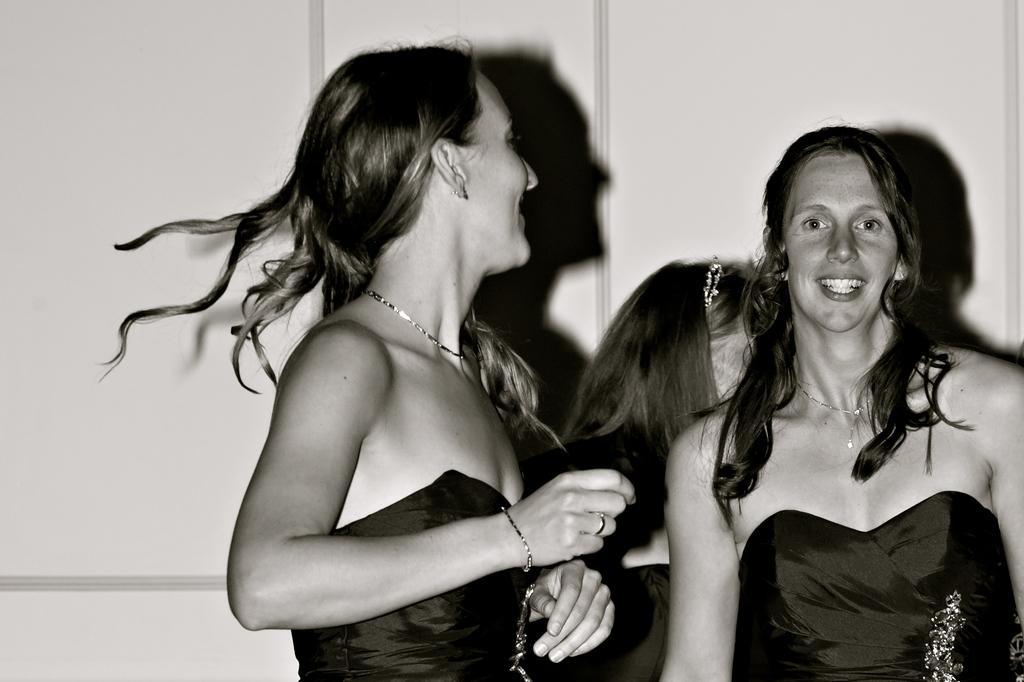How would you summarize this image in a sentence or two? In this image we can see three persons standing near the wall. 